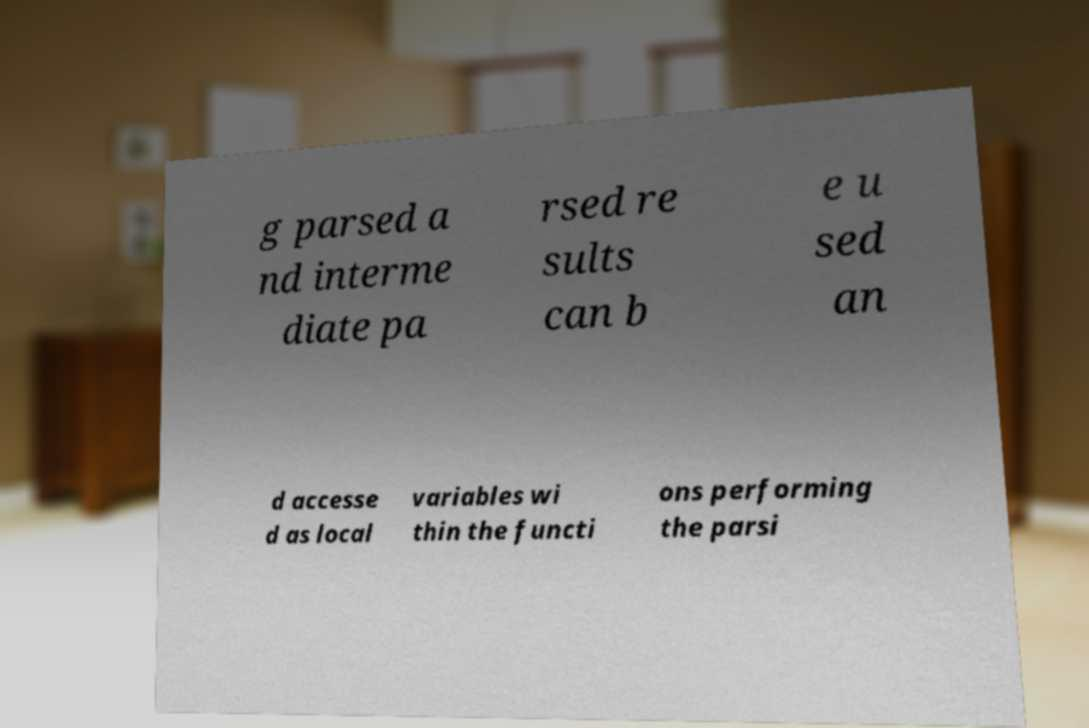Could you assist in decoding the text presented in this image and type it out clearly? g parsed a nd interme diate pa rsed re sults can b e u sed an d accesse d as local variables wi thin the functi ons performing the parsi 